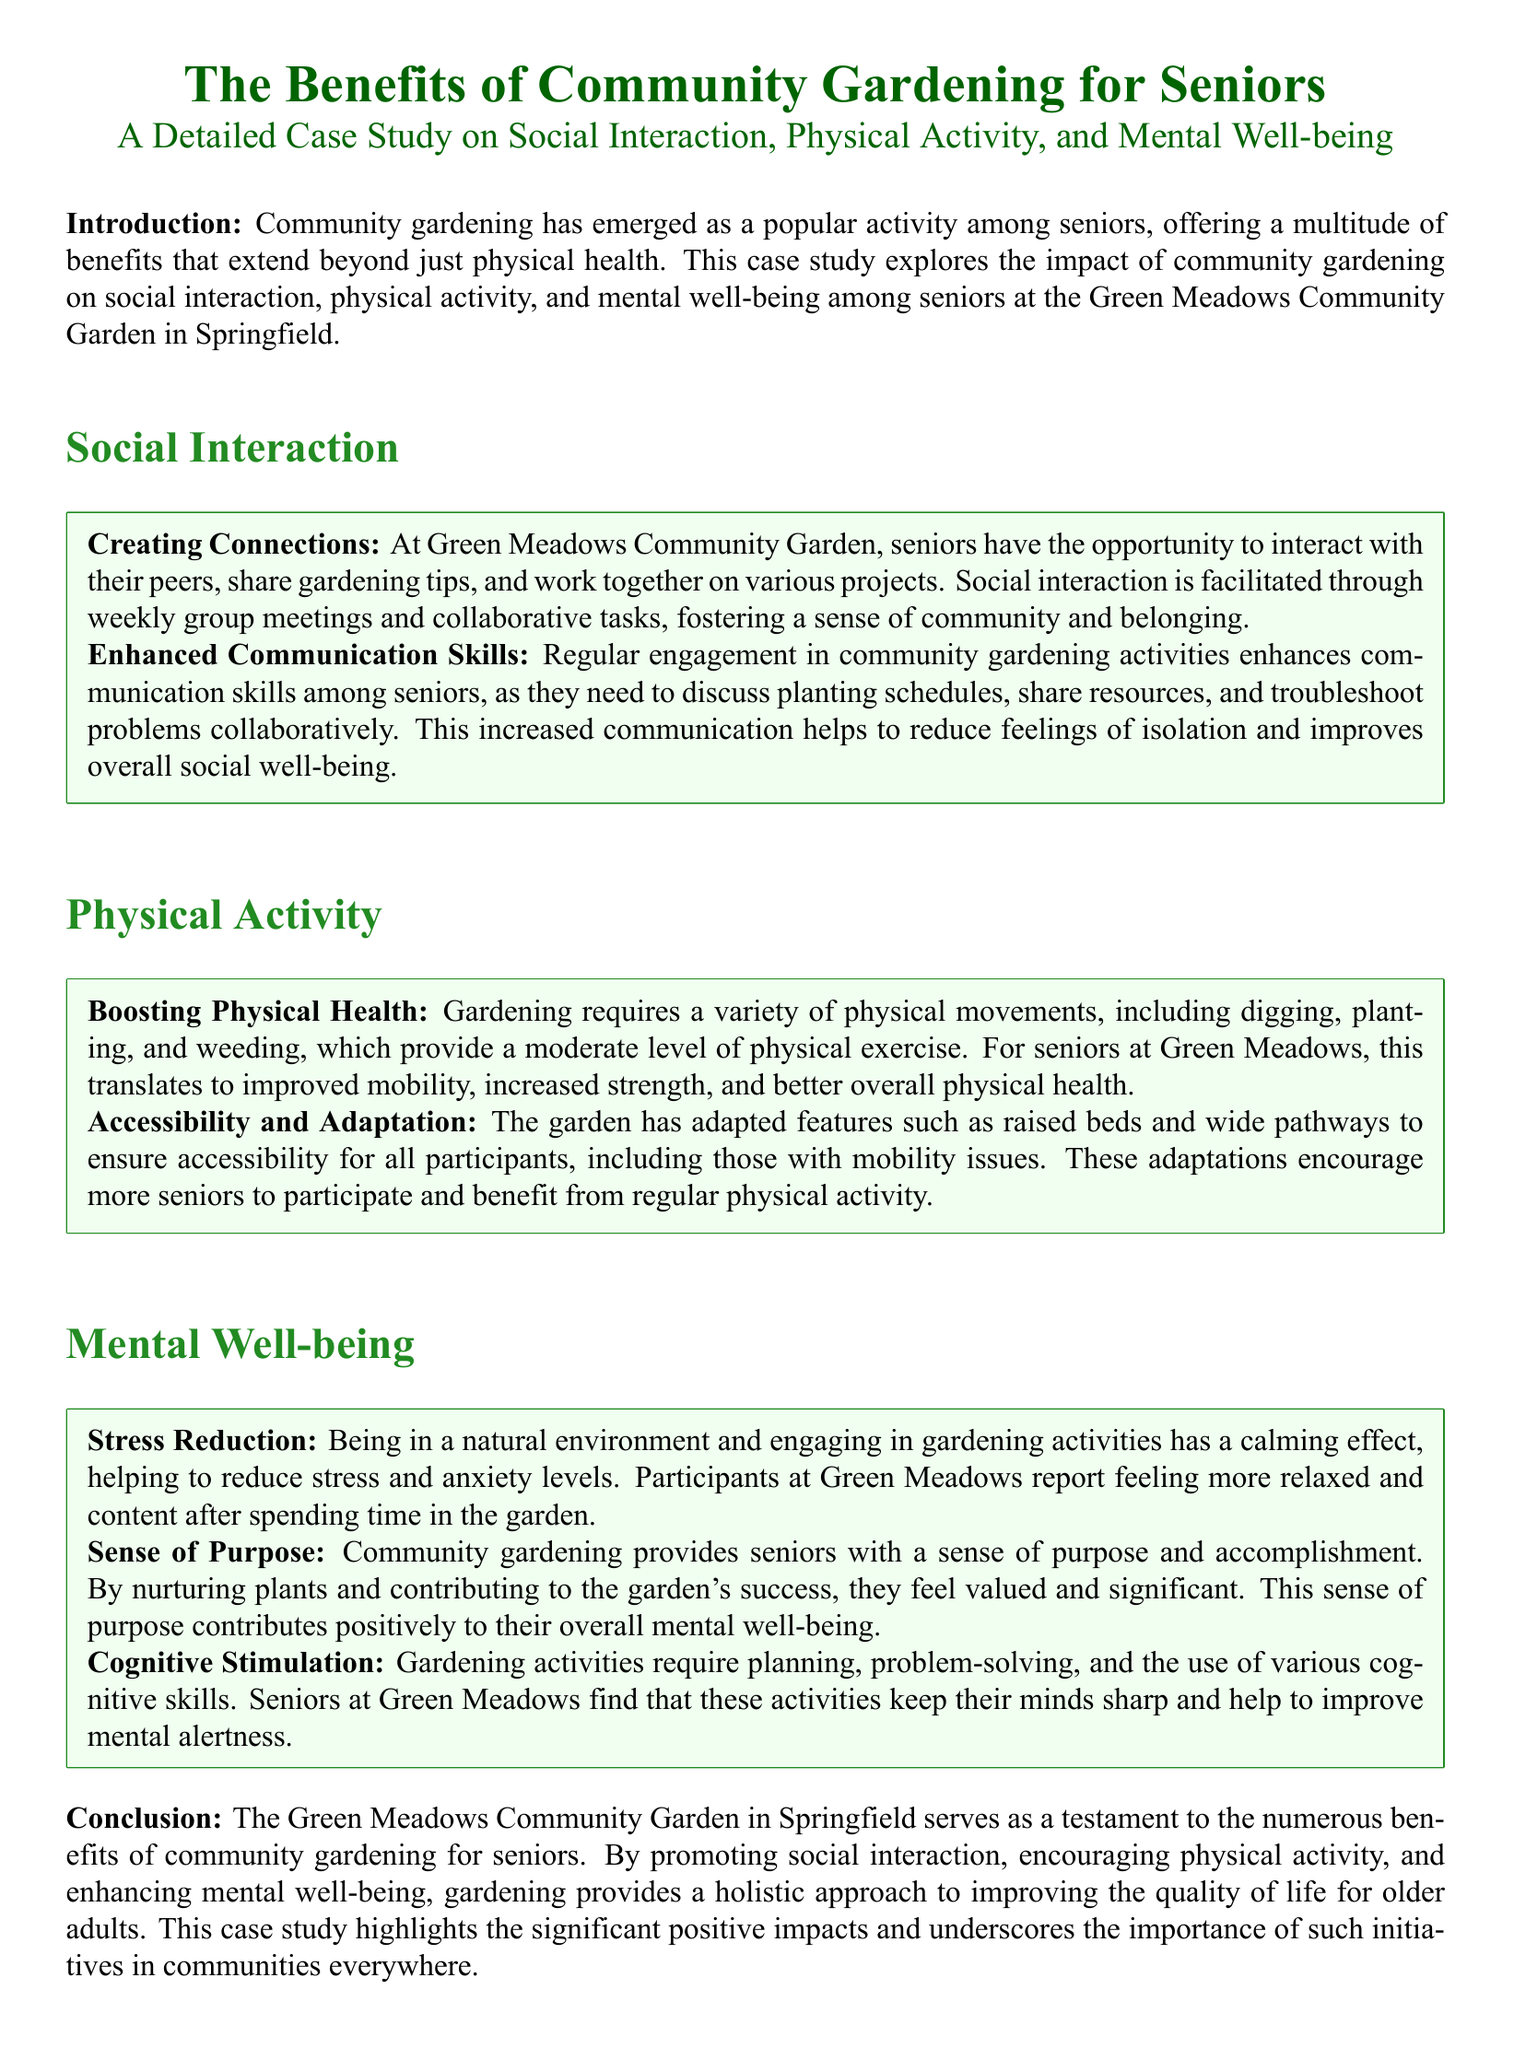What is the main topic of the case study? The main topic of the case study is about the advantages of community gardening for seniors, focusing on social interaction, physical activity, and mental well-being.
Answer: The Benefits of Community Gardening for Seniors Where is the community garden located? The community garden is located in Springfield, specifically named the Green Meadows Community Garden.
Answer: Green Meadows Community Garden in Springfield What types of skills are enhanced through gardening activities? Gardening activities help to enhance communication skills as seniors discuss various gardening aspects collaboratively.
Answer: Communication skills What physical activities do seniors engage in while gardening? Seniors engage in actions like digging, planting, and weeding, which provide moderate physical exercise.
Answer: Digging, planting, and weeding What calming effect does gardening have on participants? Gardening has a calming effect that helps to reduce stress and anxiety levels among participants.
Answer: Stress reduction What adaptations were made in the garden for accessibility? The garden includes raised beds and wide pathways to ensure accessibility for seniors, especially those with mobility issues.
Answer: Raised beds and wide pathways Which mental health aspect does community gardening provide for seniors? Community gardening provides seniors with a sense of purpose and accomplishment, positively impacting their overall mental well-being.
Answer: Sense of purpose How does gardening contribute to cognitive stimulation? Gardening activities require planning and problem-solving, keeping seniors' minds sharp and improving mental alertness.
Answer: Cognitive stimulation 